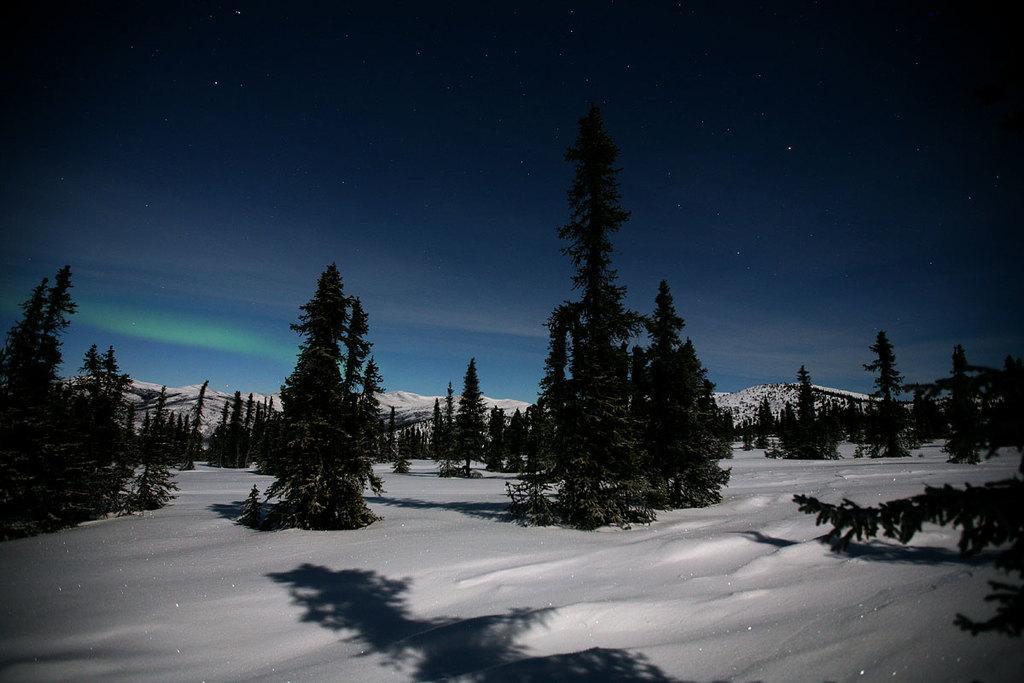In one or two sentences, can you explain what this image depicts? In this image there is snow at the bottom. On the snow there are so many trees in the line one beside the other. At the top there is the sky. In the background there are snow mountains. 